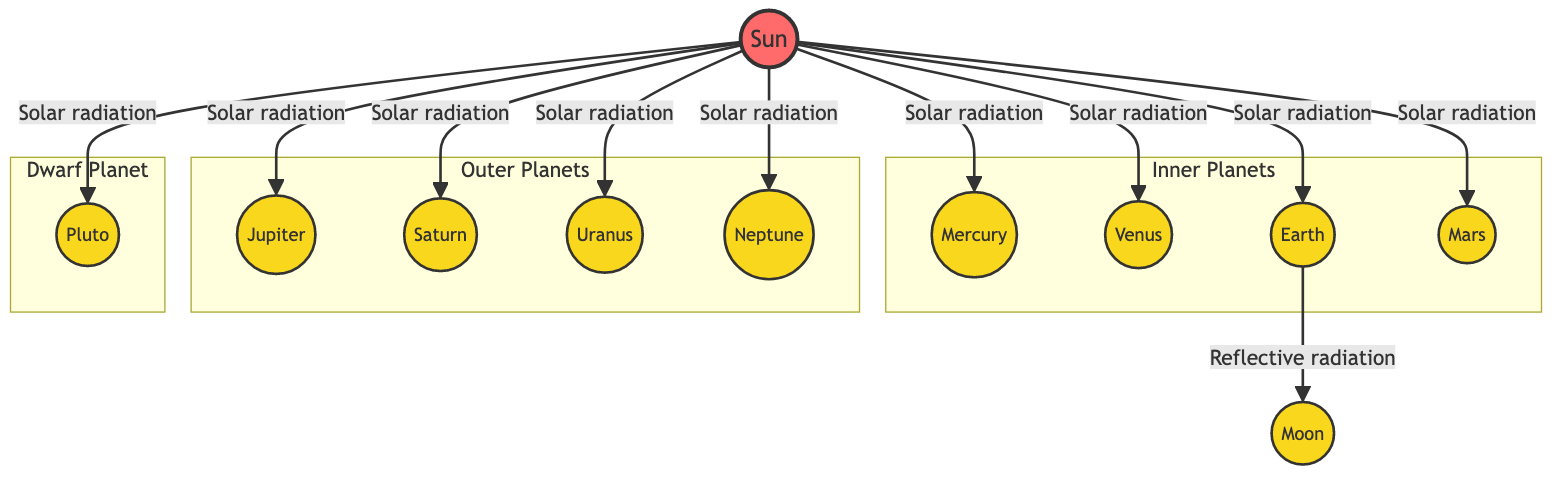What celestial body receives solar radiation from the Sun? The diagram shows arrows from the Sun directing solar radiation toward each planet, indicating that all the listed planets, including Mercury, Venus, Earth, Mars, Jupiter, Saturn, Uranus, Neptune, and Pluto, receive solar radiation.
Answer: Mercury, Venus, Earth, Mars, Jupiter, Saturn, Uranus, Neptune, Pluto How many planets are in the "Inner Planets" subgraph? The inner planets, listed in the subgraph, are Mercury, Venus, Earth, and Mars. Counting these, we find there are four planets.
Answer: 4 Which planet reflects radiation to the Moon? The diagram specifically indicates that Earth is the planet that reflects radiation towards the Moon, as indicated by the arrow labeled "Reflective radiation."
Answer: Earth How many total planets are represented in this diagram? The diagram shows a total of 10 celestial bodies, which includes 8 planets, 1 dwarf planet (Pluto), and 1 moon (Moon), adding up to ten.
Answer: 10 Which is the largest planet depicted in the diagram? The diagram illustrates that Jupiter is the largest planet in the solar system, and it is clearly represented as one of the planets directly connected to the Sun.
Answer: Jupiter What is the type of diagram illustrated here? This diagram is focused on the energy dynamics within the solar system, which is a specific type of Astronomy Diagram that illustrates solar energy exchanges.
Answer: Astronomy Diagram Which celestial bodies are in the "Outer Planets" subgraph? The "Outer Planets" subgraph includes Jupiter, Saturn, Uranus, and Neptune, as they are grouped together within that section of the diagram.
Answer: Jupiter, Saturn, Uranus, Neptune How does energy flow from the Sun to Earth? According to the diagram, energy flow from the Sun to Earth occurs via the directed arrow labeled "Solar radiation," indicating a direct energy exchange.
Answer: Solar radiation What type of energy is indicated between Earth and Moon? The diagram displays an arrow labeled "Reflective radiation" between Earth and Moon, indicating that this is the type of energy transfer occurring between these two celestial bodies.
Answer: Reflective radiation 